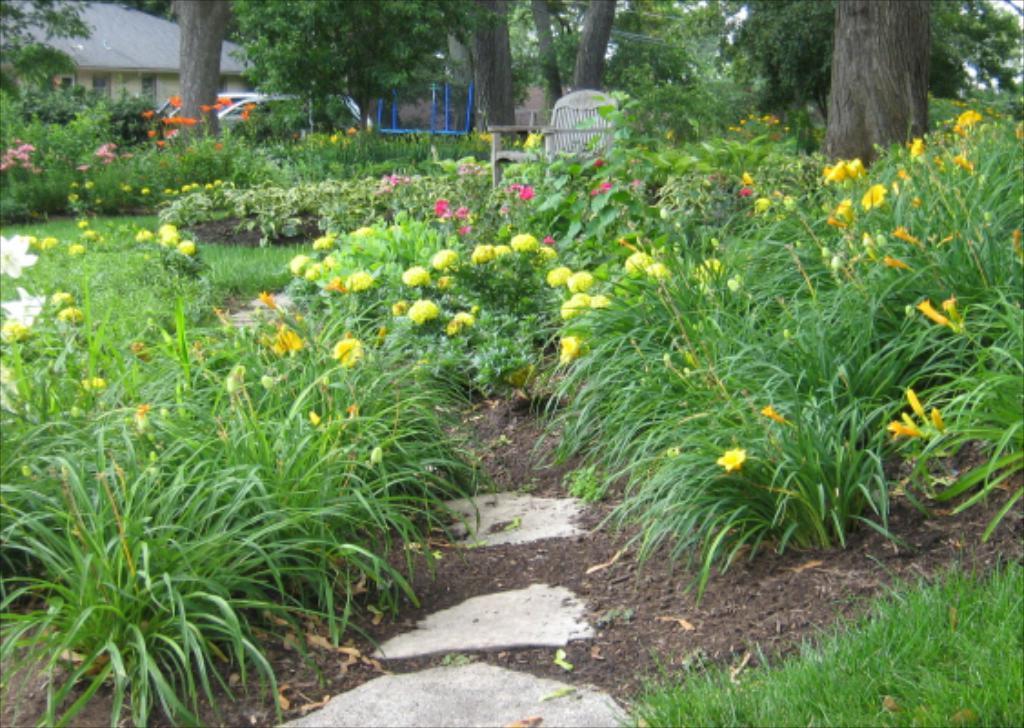Please provide a concise description of this image. In this picture, we can see the ground covered with grass, plants, flowers, trees, and we can see chair, tiles, and some objects on the ground, we can see vehicle, and building. 